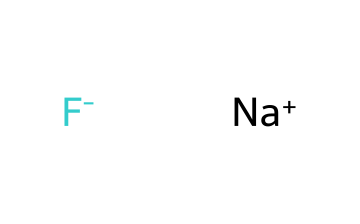What ions are present in this chemical structure? The chemical structure clearly contains sodium ions represented by "Na+" and fluoride ions represented by "F-".
Answer: sodium ions and fluoride ions How many atoms are there in this chemical? The structure includes one sodium atom and one fluoride atom, totaling two atoms in the chemical.
Answer: two What is the oxidation state of the fluoride ion? The fluoride ion, represented as "F-", carries a negative charge, indicating its oxidation state is -1.
Answer: -1 What kind of bond is expected between sodium and fluoride ions? Sodium typically forms ionic bonds with fluoride, as sodium donates an electron to become Na+, while fluoride accepts that electron to become F-.
Answer: ionic bond What is the primary reason fluoride is included in candy coatings? Fluoride is included in candy coatings primarily for its capacity to strengthen tooth enamel and prevent decay, a critical aspect in tooth-friendly products.
Answer: strengthens tooth enamel 